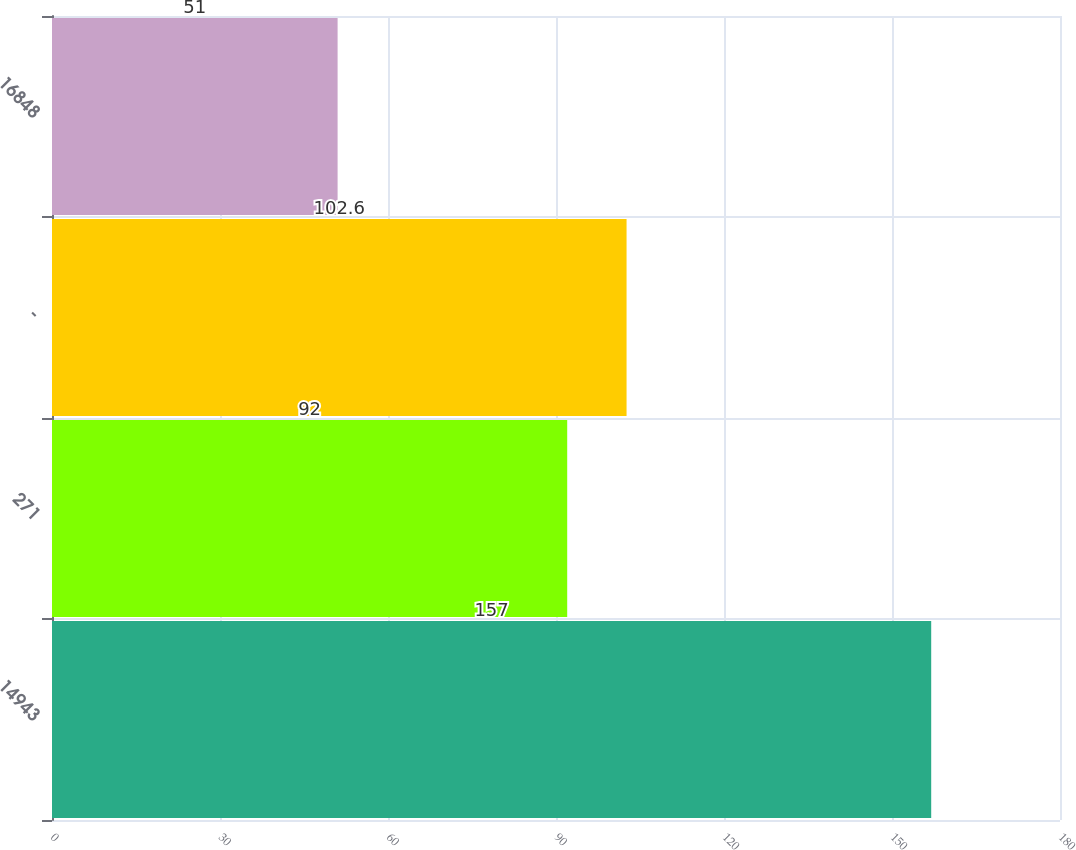Convert chart. <chart><loc_0><loc_0><loc_500><loc_500><bar_chart><fcel>14943<fcel>271<fcel>-<fcel>16848<nl><fcel>157<fcel>92<fcel>102.6<fcel>51<nl></chart> 